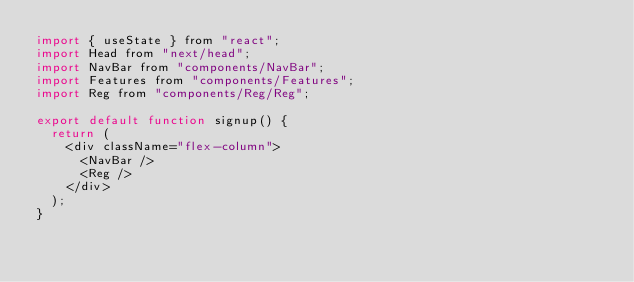<code> <loc_0><loc_0><loc_500><loc_500><_JavaScript_>import { useState } from "react";
import Head from "next/head";
import NavBar from "components/NavBar";
import Features from "components/Features";
import Reg from "components/Reg/Reg";

export default function signup() {
  return (
    <div className="flex-column">
      <NavBar />
      <Reg />
    </div>
  );
}
</code> 